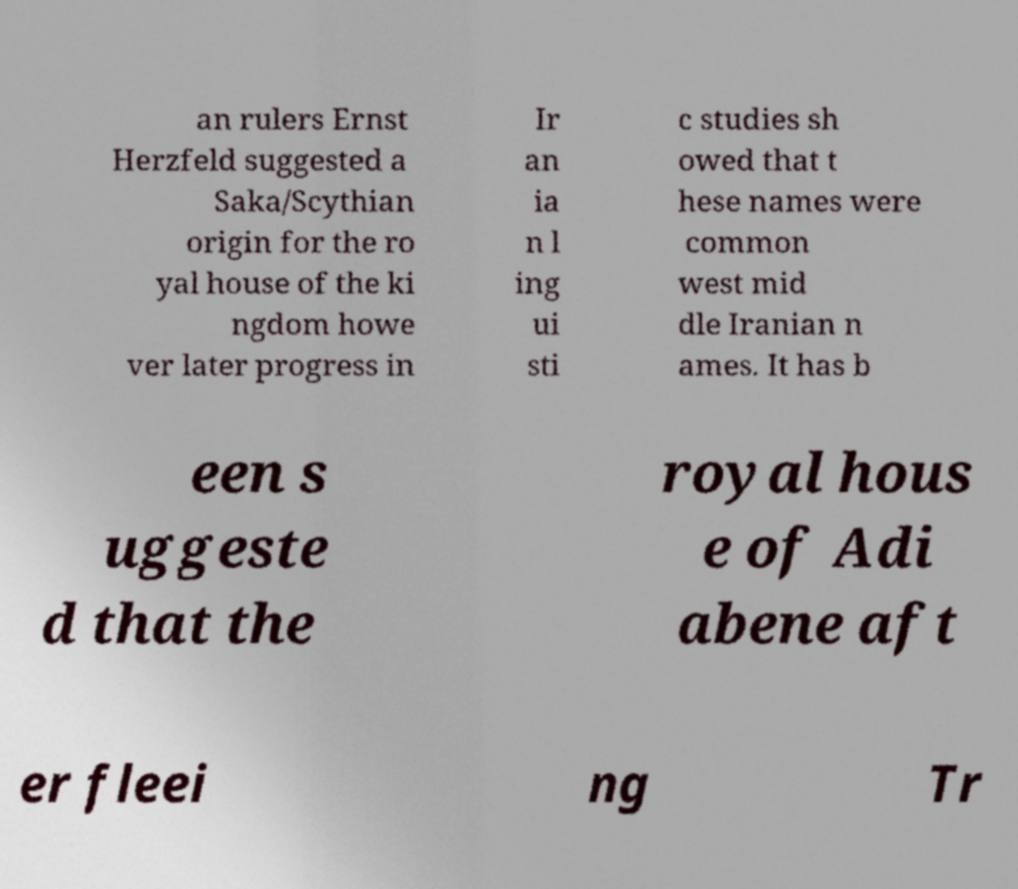Can you accurately transcribe the text from the provided image for me? an rulers Ernst Herzfeld suggested a Saka/Scythian origin for the ro yal house of the ki ngdom howe ver later progress in Ir an ia n l ing ui sti c studies sh owed that t hese names were common west mid dle Iranian n ames. It has b een s uggeste d that the royal hous e of Adi abene aft er fleei ng Tr 